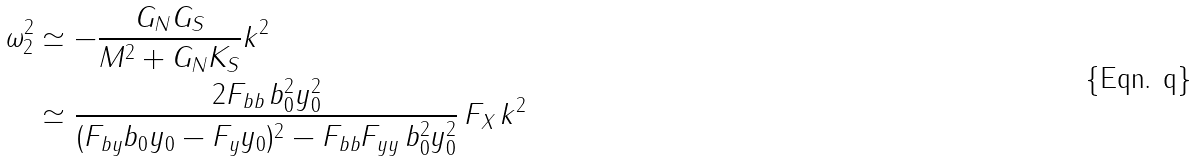<formula> <loc_0><loc_0><loc_500><loc_500>\omega ^ { 2 } _ { 2 } & \simeq - \frac { G _ { N } G _ { S } } { M ^ { 2 } + G _ { N } K _ { S } } k ^ { 2 } \\ & \simeq \frac { 2 F _ { b b } \, b _ { 0 } ^ { 2 } y _ { 0 } ^ { 2 } } { ( F _ { b y } b _ { 0 } y _ { 0 } - F _ { y } y _ { 0 } ) ^ { 2 } - F _ { b b } F _ { y y } \, b _ { 0 } ^ { 2 } y _ { 0 } ^ { 2 } } \, F _ { X } \, k ^ { 2 }</formula> 